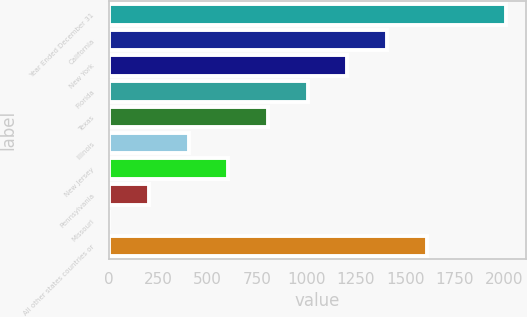Convert chart. <chart><loc_0><loc_0><loc_500><loc_500><bar_chart><fcel>Year Ended December 31<fcel>California<fcel>New York<fcel>Florida<fcel>Texas<fcel>Illinois<fcel>New Jersey<fcel>Pennsylvania<fcel>Missouri<fcel>All other states countries or<nl><fcel>2008<fcel>1406.53<fcel>1206.04<fcel>1005.55<fcel>805.06<fcel>404.08<fcel>604.57<fcel>203.59<fcel>3.1<fcel>1607.02<nl></chart> 